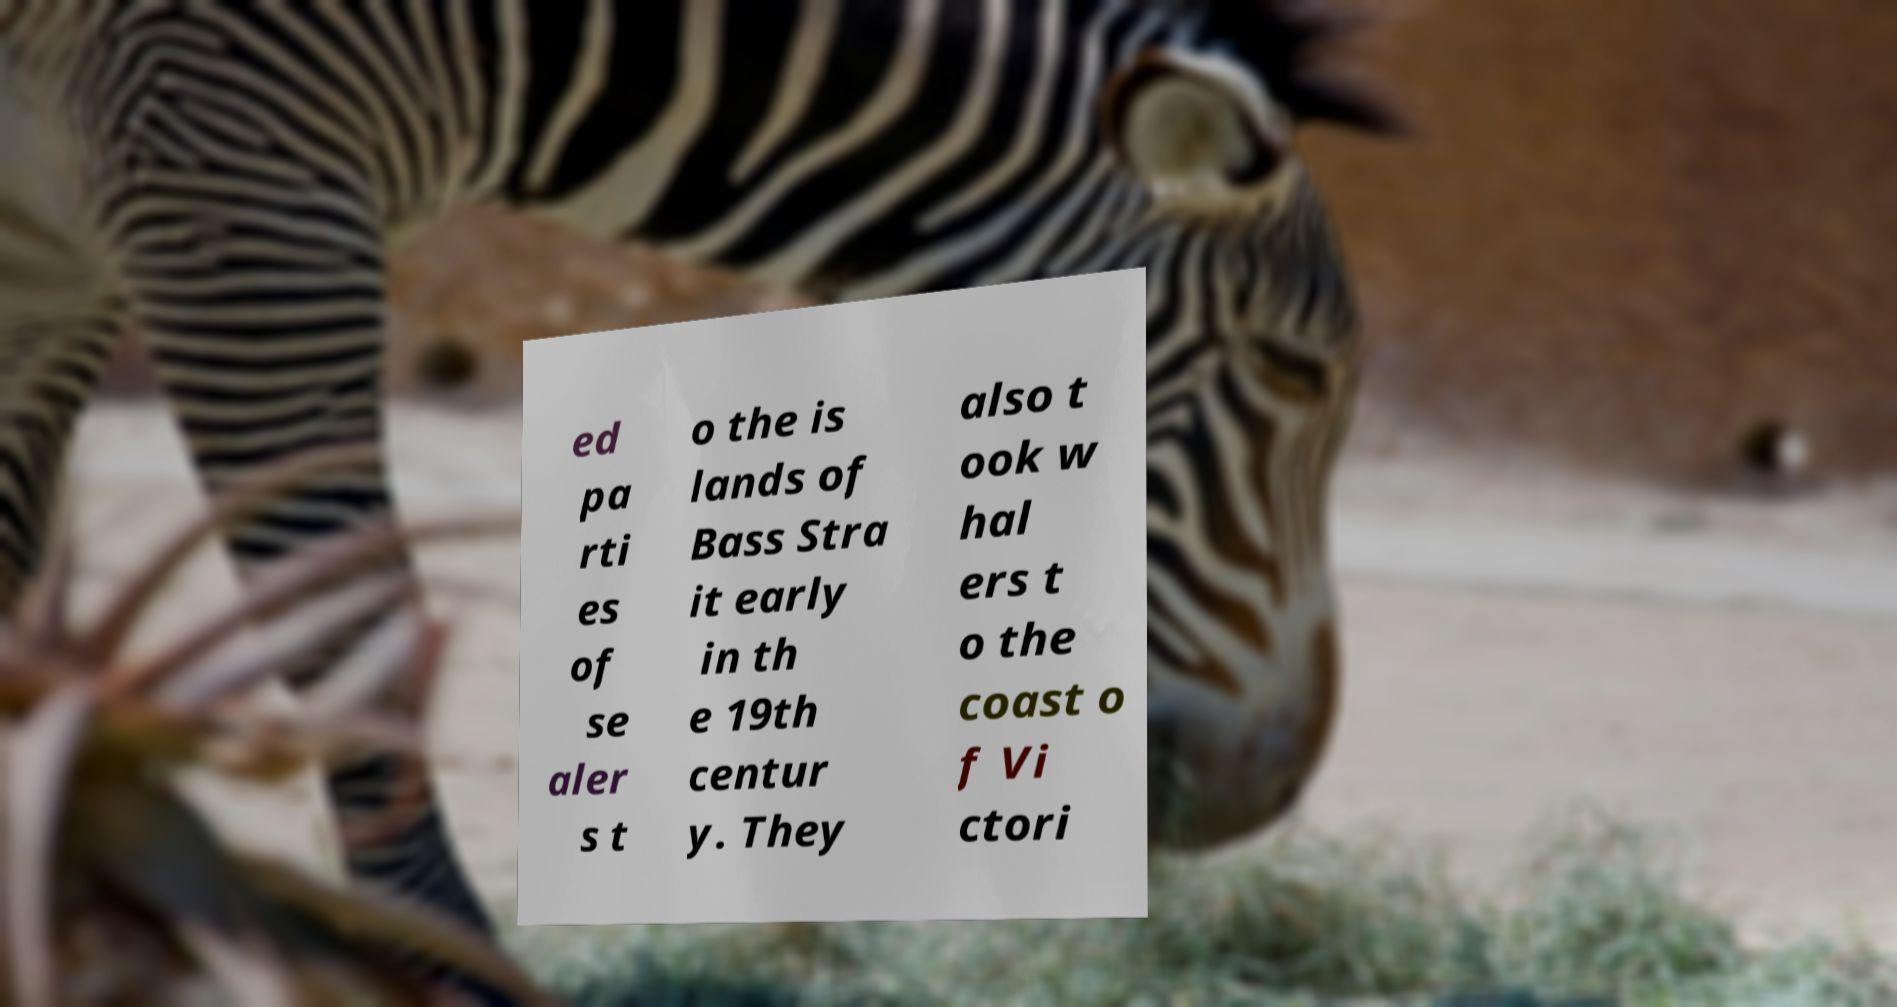Can you read and provide the text displayed in the image?This photo seems to have some interesting text. Can you extract and type it out for me? ed pa rti es of se aler s t o the is lands of Bass Stra it early in th e 19th centur y. They also t ook w hal ers t o the coast o f Vi ctori 